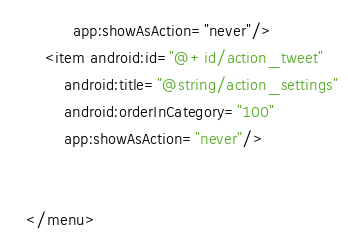<code> <loc_0><loc_0><loc_500><loc_500><_XML_>          app:showAsAction="never"/>
    <item android:id="@+id/action_tweet"
        android:title="@string/action_settings"
        android:orderInCategory="100"
        app:showAsAction="never"/>


</menu>
</code> 